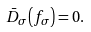<formula> <loc_0><loc_0><loc_500><loc_500>\bar { D } _ { \sigma } \left ( f _ { \sigma } \right ) = 0 .</formula> 